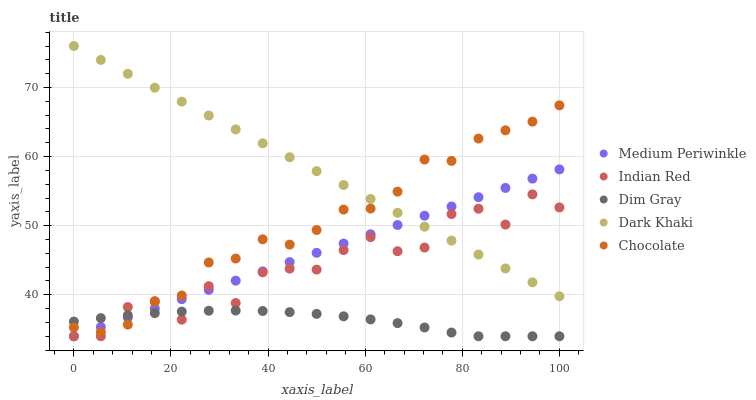Does Dim Gray have the minimum area under the curve?
Answer yes or no. Yes. Does Dark Khaki have the maximum area under the curve?
Answer yes or no. Yes. Does Medium Periwinkle have the minimum area under the curve?
Answer yes or no. No. Does Medium Periwinkle have the maximum area under the curve?
Answer yes or no. No. Is Medium Periwinkle the smoothest?
Answer yes or no. Yes. Is Indian Red the roughest?
Answer yes or no. Yes. Is Dim Gray the smoothest?
Answer yes or no. No. Is Dim Gray the roughest?
Answer yes or no. No. Does Dim Gray have the lowest value?
Answer yes or no. Yes. Does Chocolate have the lowest value?
Answer yes or no. No. Does Dark Khaki have the highest value?
Answer yes or no. Yes. Does Medium Periwinkle have the highest value?
Answer yes or no. No. Is Dim Gray less than Dark Khaki?
Answer yes or no. Yes. Is Dark Khaki greater than Dim Gray?
Answer yes or no. Yes. Does Chocolate intersect Indian Red?
Answer yes or no. Yes. Is Chocolate less than Indian Red?
Answer yes or no. No. Is Chocolate greater than Indian Red?
Answer yes or no. No. Does Dim Gray intersect Dark Khaki?
Answer yes or no. No. 